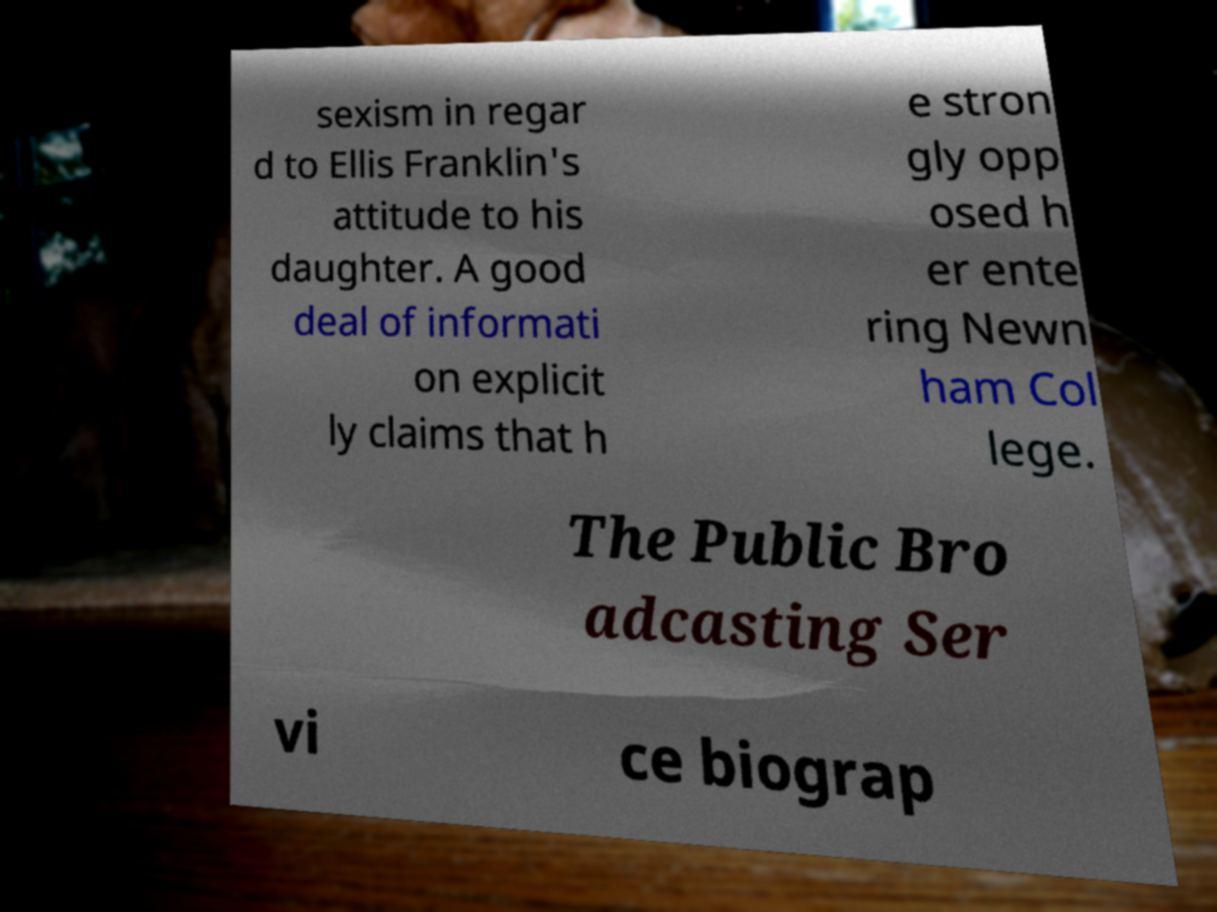Could you extract and type out the text from this image? sexism in regar d to Ellis Franklin's attitude to his daughter. A good deal of informati on explicit ly claims that h e stron gly opp osed h er ente ring Newn ham Col lege. The Public Bro adcasting Ser vi ce biograp 